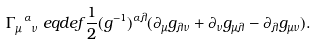<formula> <loc_0><loc_0><loc_500><loc_500>\Gamma _ { \mu \ \nu } ^ { \ \alpha } & \ e q d e f \frac { 1 } { 2 } ( g ^ { - 1 } ) ^ { \alpha \lambda } ( \partial _ { \mu } g _ { \lambda \nu } + \partial _ { \nu } g _ { \mu \lambda } - \partial _ { \lambda } g _ { \mu \nu } ) .</formula> 